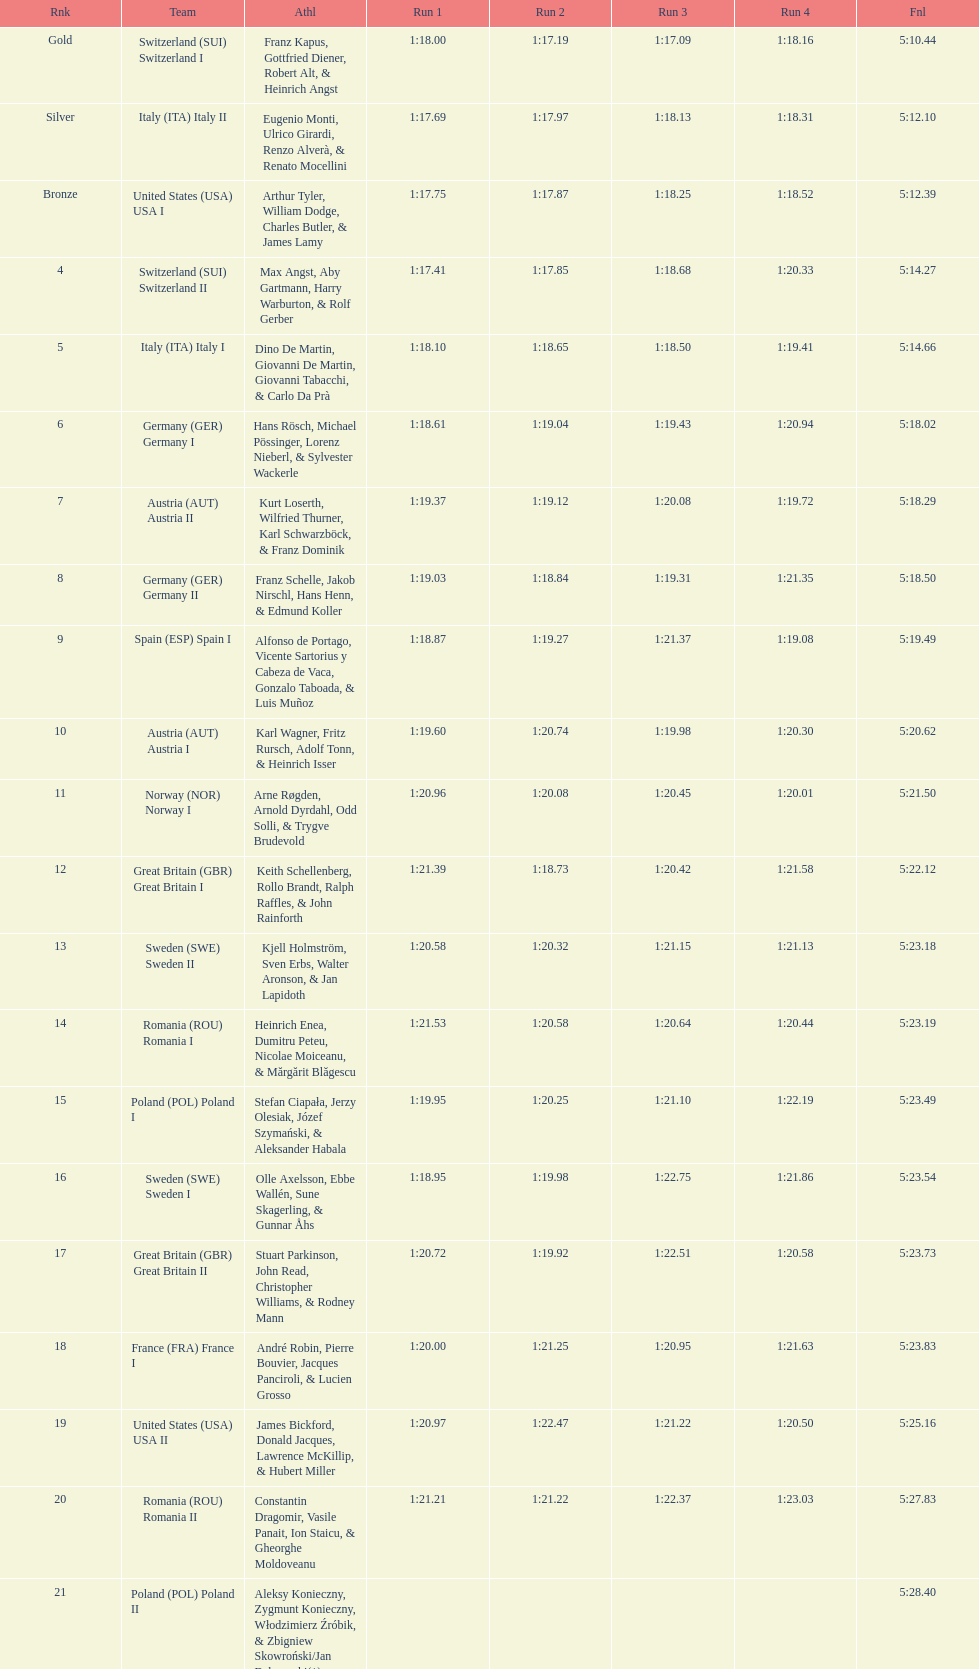What team came out on top? Switzerland. 